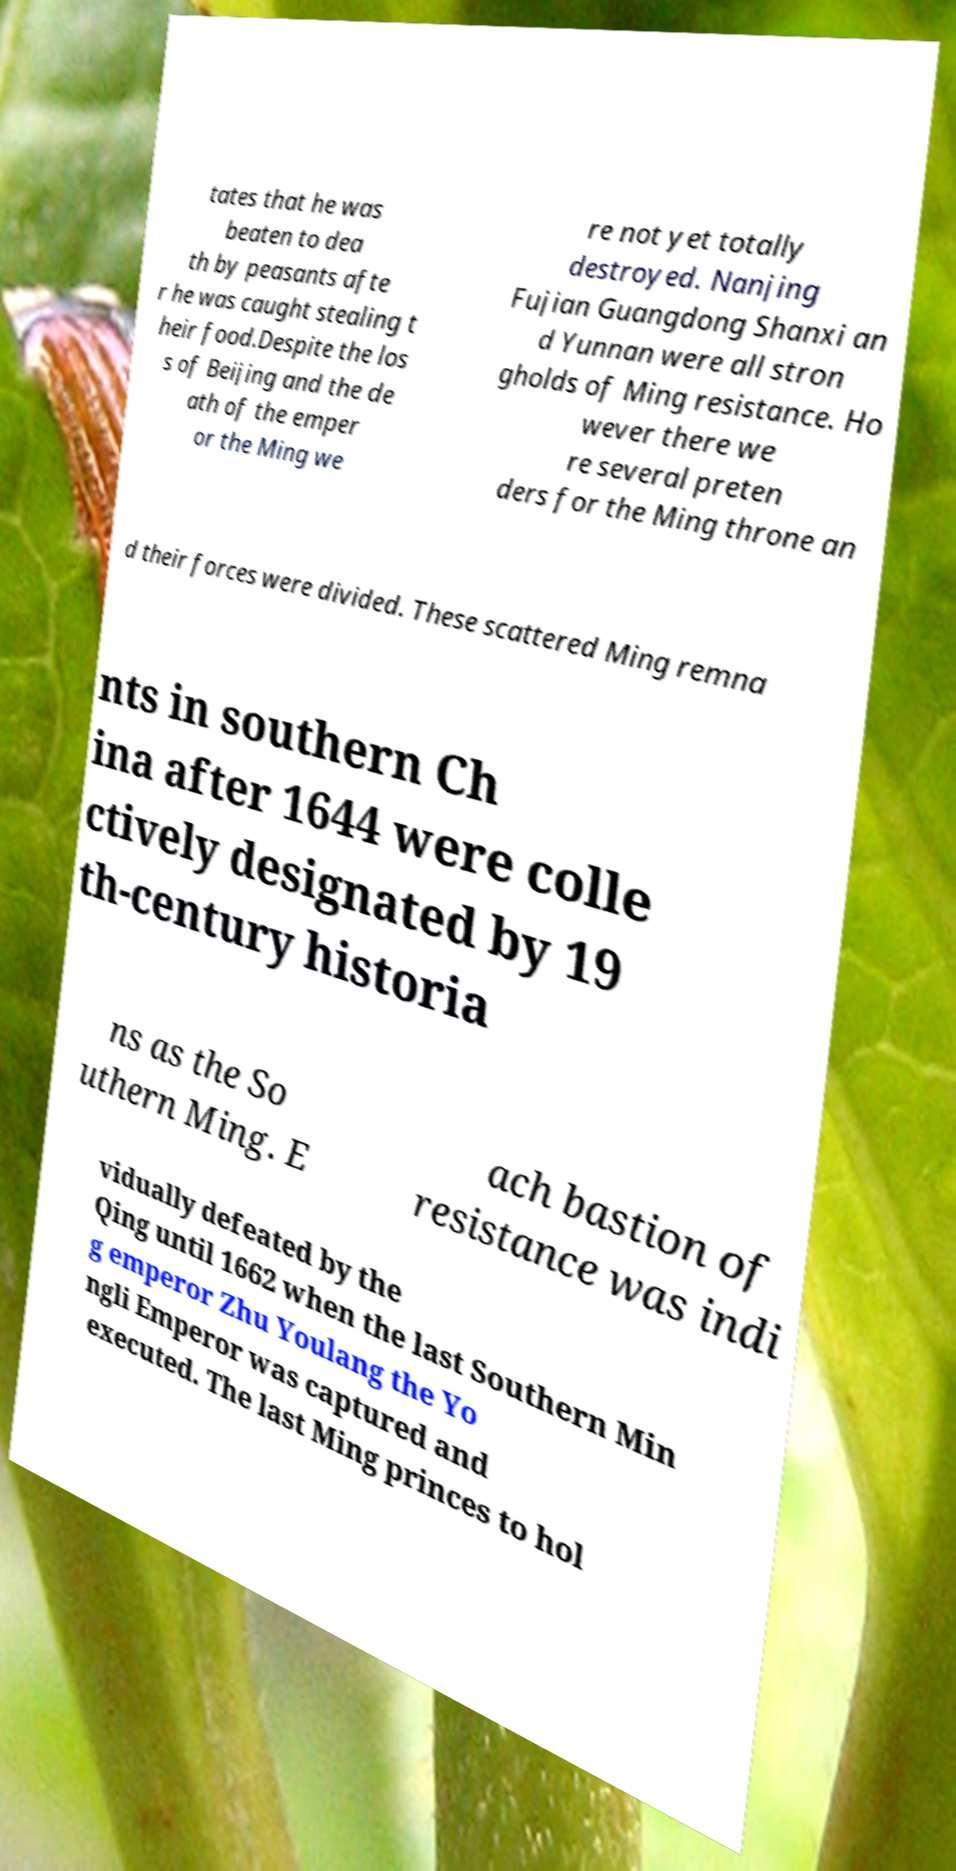There's text embedded in this image that I need extracted. Can you transcribe it verbatim? tates that he was beaten to dea th by peasants afte r he was caught stealing t heir food.Despite the los s of Beijing and the de ath of the emper or the Ming we re not yet totally destroyed. Nanjing Fujian Guangdong Shanxi an d Yunnan were all stron gholds of Ming resistance. Ho wever there we re several preten ders for the Ming throne an d their forces were divided. These scattered Ming remna nts in southern Ch ina after 1644 were colle ctively designated by 19 th-century historia ns as the So uthern Ming. E ach bastion of resistance was indi vidually defeated by the Qing until 1662 when the last Southern Min g emperor Zhu Youlang the Yo ngli Emperor was captured and executed. The last Ming princes to hol 